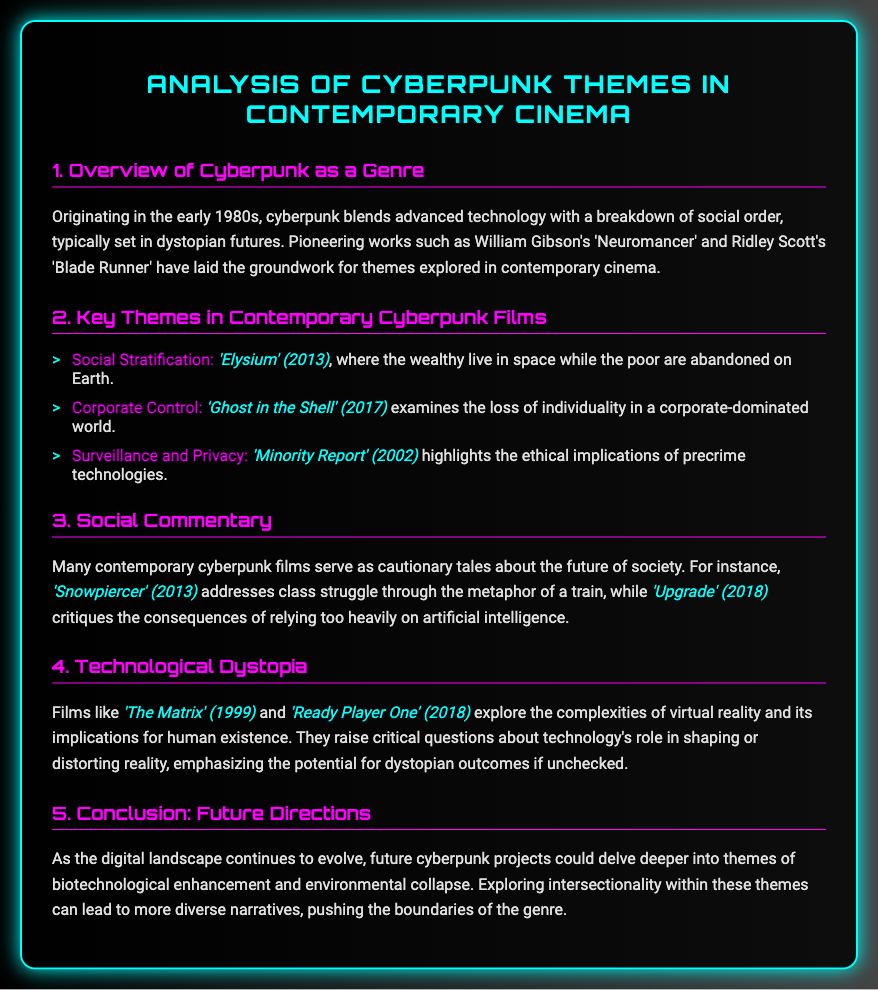What is the title of the memo? The title is located at the top of the document and states the main topic being analyzed.
Answer: Analysis of Cyberpunk Themes in Contemporary Cinema What year did cyberpunk originate? The document provides specific information about the origins of cyberpunk as a genre in the early 1980s.
Answer: early 1980s Which film examines corporate control? The document lists specific films under key themes, and corporate control is explored in one of them.
Answer: Ghost in the Shell (2017) What theme is represented in 'Elysium'? The theme is identified in the list of key themes, specifically relating to the setting and social status depicted in the film.
Answer: Social Stratification What metaphor is used in 'Snowpiercer'? The memo mentions a specific metaphor that addresses class struggle in the context of the film's setting.
Answer: a train Which themes could future cyberpunk projects explore? The document suggests potential future themes for exploration, focusing on emerging societal issues.
Answer: biotechnological enhancement and environmental collapse 